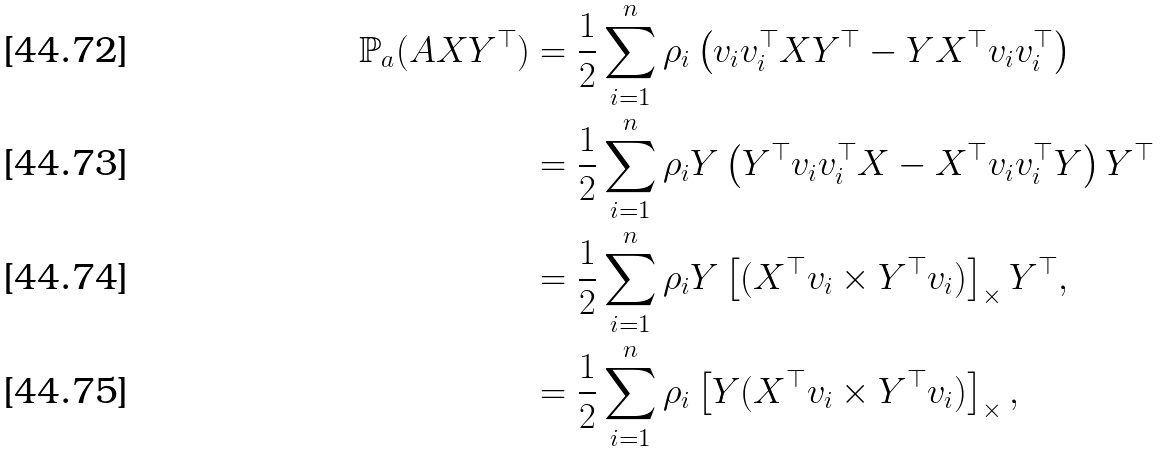Convert formula to latex. <formula><loc_0><loc_0><loc_500><loc_500>\mathbb { P } _ { a } ( A X Y ^ { \top } ) & = \frac { 1 } { 2 } \sum _ { i = 1 } ^ { n } \rho _ { i } \left ( v _ { i } v _ { i } ^ { \top } X Y ^ { \top } - Y X ^ { \top } v _ { i } v _ { i } ^ { \top } \right ) \\ & = \frac { 1 } { 2 } \sum _ { i = 1 } ^ { n } \rho _ { i } Y \left ( Y ^ { \top } v _ { i } v _ { i } ^ { \top } X - X ^ { \top } v _ { i } v _ { i } ^ { \top } Y \right ) Y ^ { \top } \\ & = \frac { 1 } { 2 } \sum _ { i = 1 } ^ { n } \rho _ { i } Y \left [ ( X ^ { \top } v _ { i } \times Y ^ { \top } v _ { i } ) \right ] _ { \times } Y ^ { \top } , \\ & = \frac { 1 } { 2 } \sum _ { i = 1 } ^ { n } \rho _ { i } \left [ Y ( X ^ { \top } v _ { i } \times Y ^ { \top } v _ { i } ) \right ] _ { \times } ,</formula> 